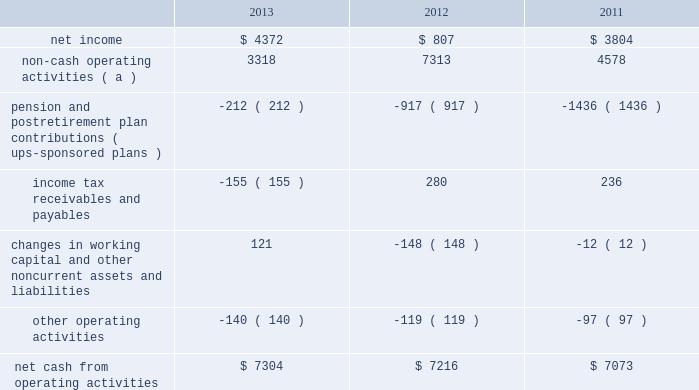United parcel service , inc .
And subsidiaries management's discussion and analysis of financial condition and results of operations liquidity and capital resources operating activities the following is a summary of the significant sources ( uses ) of cash from operating activities ( amounts in millions ) : .
( a ) represents depreciation and amortization , gains and losses on derivative and foreign exchange transactions , deferred income taxes , provisions for uncollectible accounts , pension and postretirement benefit expense , stock compensation expense , impairment charges and other non-cash items .
Cash from operating activities remained strong throughout the 2011 to 2013 time period .
Operating cash flow was favorably impacted in 2013 , compared with 2012 , by lower contributions into our defined benefit pension and postretirement benefit plans ; however , this was partially offset by certain tnt express transaction-related charges , as well as changes in income tax receivables and payables .
We paid a termination fee to tnt express of 20ac200 million ( $ 268 million ) under the agreement to terminate the merger protocol in the first quarter of 2013 .
Additionally , the cash payments for income taxes increased in 2013 compared with 2012 , and were impacted by the timing of current tax deductions .
Except for discretionary or accelerated fundings of our plans , contributions to our company-sponsored pension plans have largely varied based on whether any minimum funding requirements are present for individual pension plans .
2022 in 2013 , we did not have any required , nor make any discretionary , contributions to our primary company-sponsored pension plans in the u.s .
2022 in 2012 , we made a $ 355 million required contribution to the ups ibt pension plan .
2022 in 2011 , we made a $ 1.2 billion contribution to the ups ibt pension plan , which satisfied our 2011 contribution requirements and also approximately $ 440 million in contributions that would not have been required until after 2011 .
2022 the remaining contributions in the 2011 through 2013 period were largely due to contributions to our international pension plans and u.s .
Postretirement medical benefit plans .
As discussed further in the 201ccontractual commitments 201d section , we have minimum funding requirements in the next several years , primarily related to the ups ibt pension , ups retirement and ups pension plans .
As of december 31 , 2013 , the total of our worldwide holdings of cash and cash equivalents was $ 4.665 billion .
Approximately 45%-55% ( 45%-55 % ) of cash and cash equivalents was held by foreign subsidiaries throughout the year .
The amount of cash held by our u.s .
And foreign subsidiaries fluctuates throughout the year due to a variety of factors , including the timing of cash receipts and disbursements in the normal course of business .
Cash provided by operating activities in the united states continues to be our primary source of funds to finance domestic operating needs , capital expenditures , share repurchases and dividend payments to shareowners .
To the extent that such amounts represent previously untaxed earnings , the cash held by foreign subsidiaries would be subject to tax if such amounts were repatriated in the form of dividends ; however , not all international cash balances would have to be repatriated in the form of a dividend if returned to the u.s .
When amounts earned by foreign subsidiaries are expected to be indefinitely reinvested , no accrual for taxes is provided. .
What was the percentage change in net cash from operating activities from 2011 to 2012? 
Computations: ((7216 - 7073) / 7073)
Answer: 0.02022. 